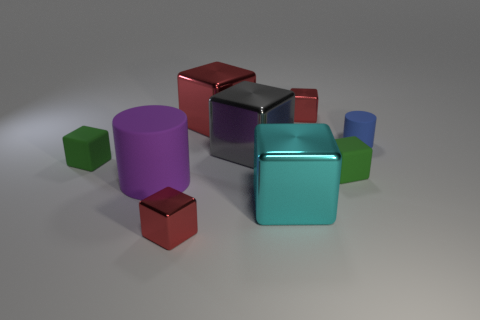The small block that is left of the big red object and to the right of the purple rubber cylinder is what color?
Make the answer very short. Red. What number of tiny objects are blue shiny cubes or blue matte things?
Make the answer very short. 1. Is there any other thing of the same color as the large cylinder?
Make the answer very short. No. The red cube that is in front of the green rubber cube that is to the left of the red shiny thing that is to the right of the large gray metallic cube is made of what material?
Make the answer very short. Metal. What number of metal things are either green blocks or red objects?
Offer a very short reply. 3. What number of cyan things are either large rubber spheres or matte objects?
Keep it short and to the point. 0. There is a cylinder that is behind the big purple rubber cylinder; does it have the same color as the big rubber cylinder?
Make the answer very short. No. Does the big cyan cube have the same material as the purple cylinder?
Keep it short and to the point. No. Is the number of small green rubber cubes behind the blue matte cylinder the same as the number of tiny green rubber things that are left of the big matte thing?
Offer a very short reply. No. There is a blue object that is the same shape as the purple thing; what is it made of?
Offer a very short reply. Rubber. 